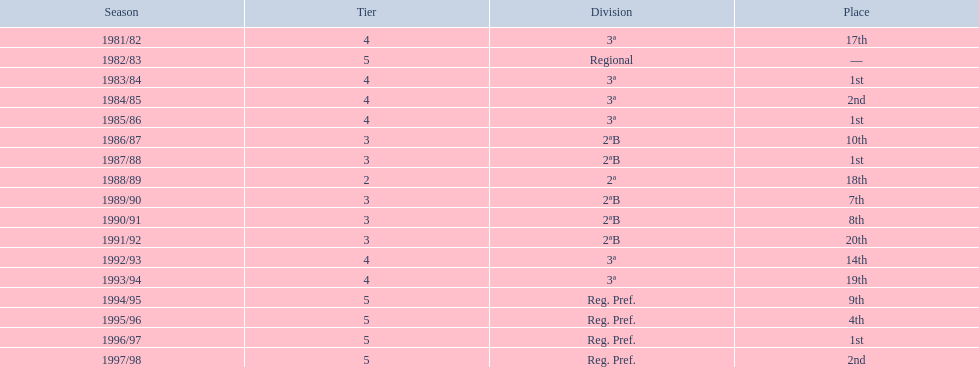In what years did the team engage in a season? 1981/82, 1982/83, 1983/84, 1984/85, 1985/86, 1986/87, 1987/88, 1988/89, 1989/90, 1990/91, 1991/92, 1992/93, 1993/94, 1994/95, 1995/96, 1996/97, 1997/98. Among those years, when did they stand outside the top 10? 1981/82, 1988/89, 1991/92, 1992/93, 1993/94. In the years they stood outside the top 10, when did they demonstrate their weakest performance? 1991/92. 